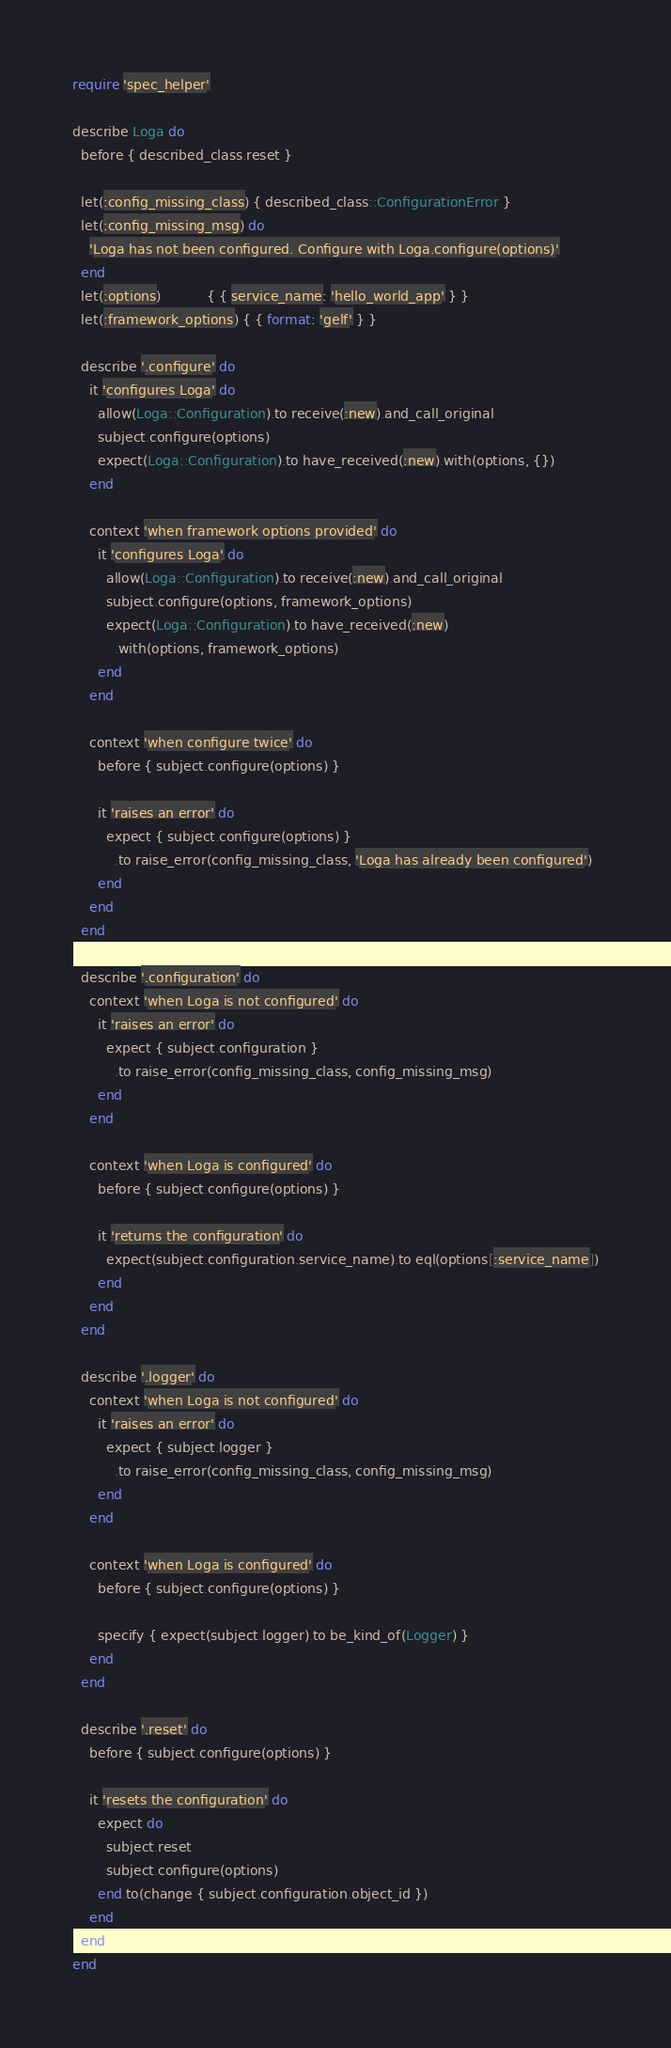Convert code to text. <code><loc_0><loc_0><loc_500><loc_500><_Ruby_>require 'spec_helper'

describe Loga do
  before { described_class.reset }

  let(:config_missing_class) { described_class::ConfigurationError }
  let(:config_missing_msg) do
    'Loga has not been configured. Configure with Loga.configure(options)'
  end
  let(:options)           { { service_name: 'hello_world_app' } }
  let(:framework_options) { { format: 'gelf' } }

  describe '.configure' do
    it 'configures Loga' do
      allow(Loga::Configuration).to receive(:new).and_call_original
      subject.configure(options)
      expect(Loga::Configuration).to have_received(:new).with(options, {})
    end

    context 'when framework options provided' do
      it 'configures Loga' do
        allow(Loga::Configuration).to receive(:new).and_call_original
        subject.configure(options, framework_options)
        expect(Loga::Configuration).to have_received(:new)
          .with(options, framework_options)
      end
    end

    context 'when configure twice' do
      before { subject.configure(options) }

      it 'raises an error' do
        expect { subject.configure(options) }
          .to raise_error(config_missing_class, 'Loga has already been configured')
      end
    end
  end

  describe '.configuration' do
    context 'when Loga is not configured' do
      it 'raises an error' do
        expect { subject.configuration }
          .to raise_error(config_missing_class, config_missing_msg)
      end
    end

    context 'when Loga is configured' do
      before { subject.configure(options) }

      it 'returns the configuration' do
        expect(subject.configuration.service_name).to eql(options[:service_name])
      end
    end
  end

  describe '.logger' do
    context 'when Loga is not configured' do
      it 'raises an error' do
        expect { subject.logger }
          .to raise_error(config_missing_class, config_missing_msg)
      end
    end

    context 'when Loga is configured' do
      before { subject.configure(options) }

      specify { expect(subject.logger).to be_kind_of(Logger) }
    end
  end

  describe '.reset' do
    before { subject.configure(options) }

    it 'resets the configuration' do
      expect do
        subject.reset
        subject.configure(options)
      end.to(change { subject.configuration.object_id })
    end
  end
end
</code> 